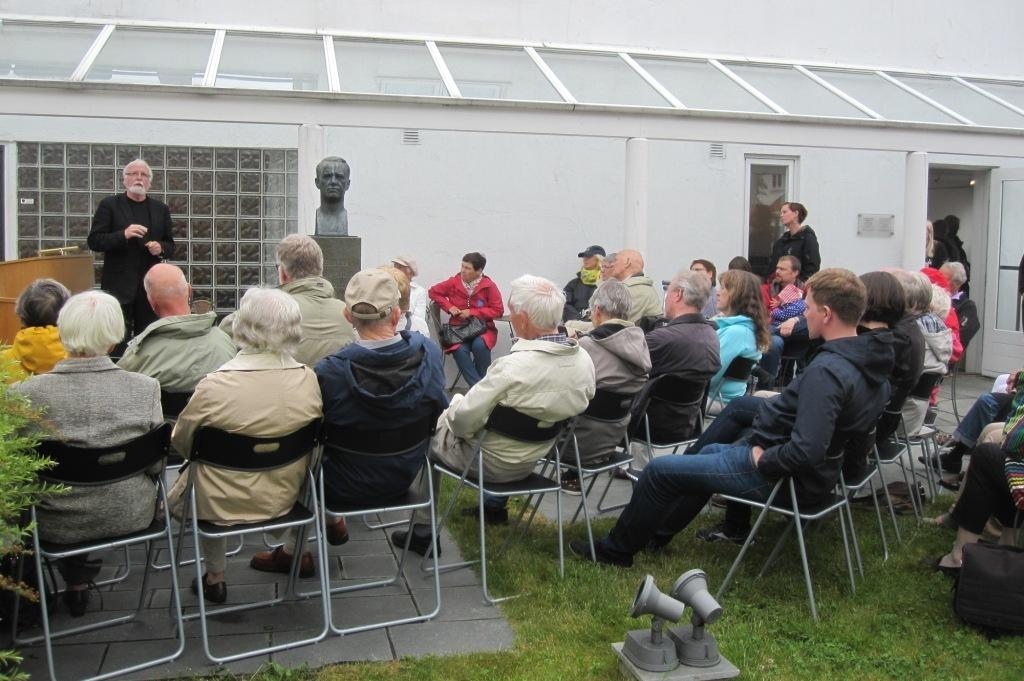What are the people in the image doing? There is a group of people sitting on chairs in the image. What direction are the people looking? The people are looking to the left side. Is there anyone standing in the image? Yes, there is a person standing on the left side. What can be seen on the right side of the image? There is a door on the right side. What type of river can be seen flowing quietly in the background of the image? There is no river present in the image, and the image does not depict a background. 